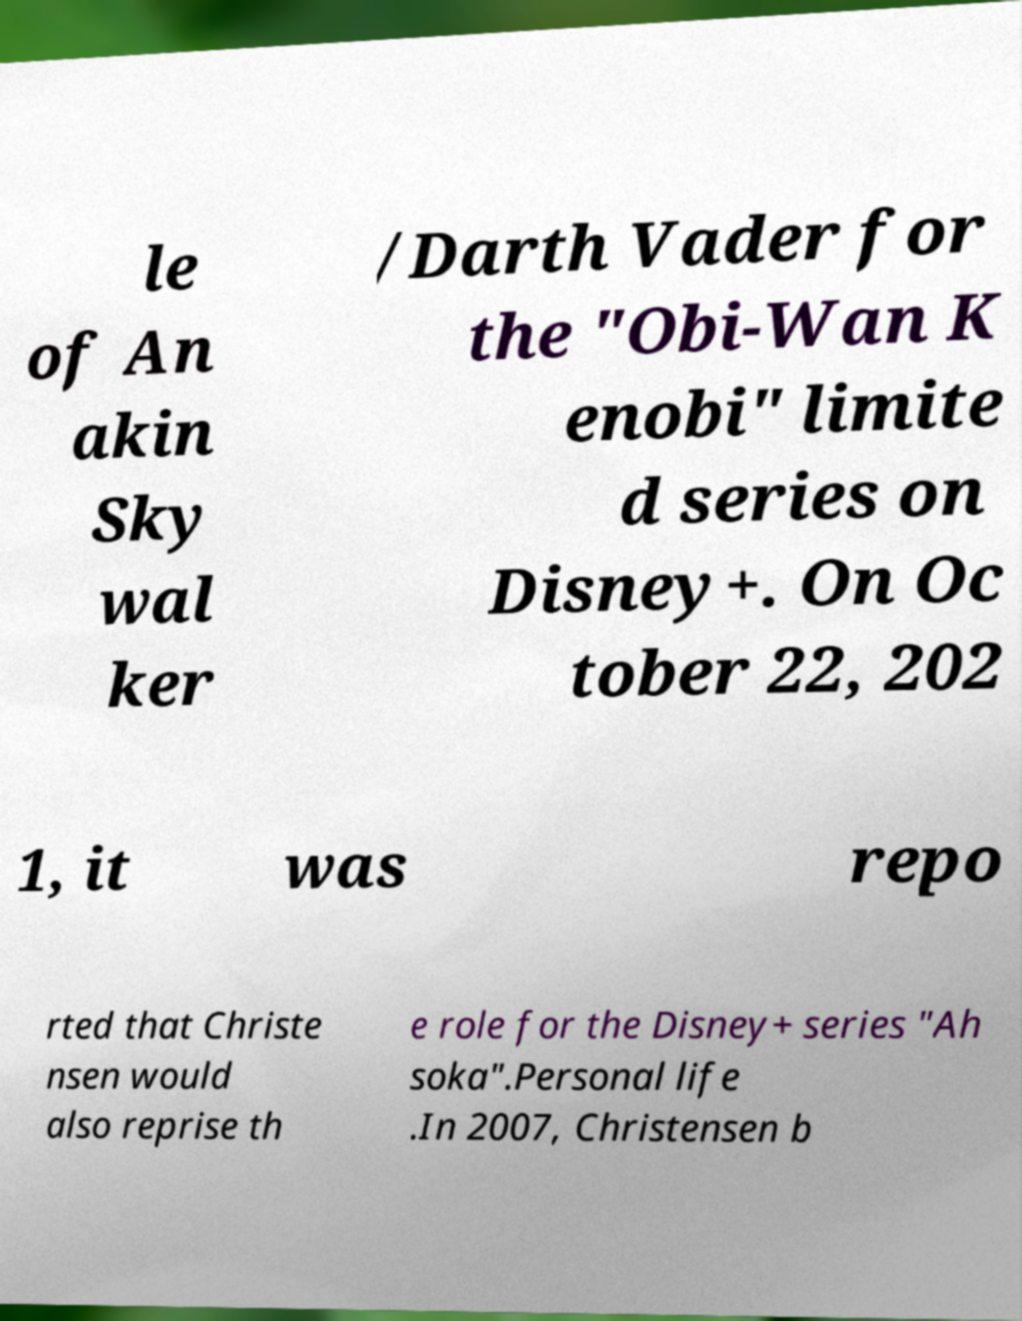I need the written content from this picture converted into text. Can you do that? le of An akin Sky wal ker /Darth Vader for the "Obi-Wan K enobi" limite d series on Disney+. On Oc tober 22, 202 1, it was repo rted that Christe nsen would also reprise th e role for the Disney+ series "Ah soka".Personal life .In 2007, Christensen b 